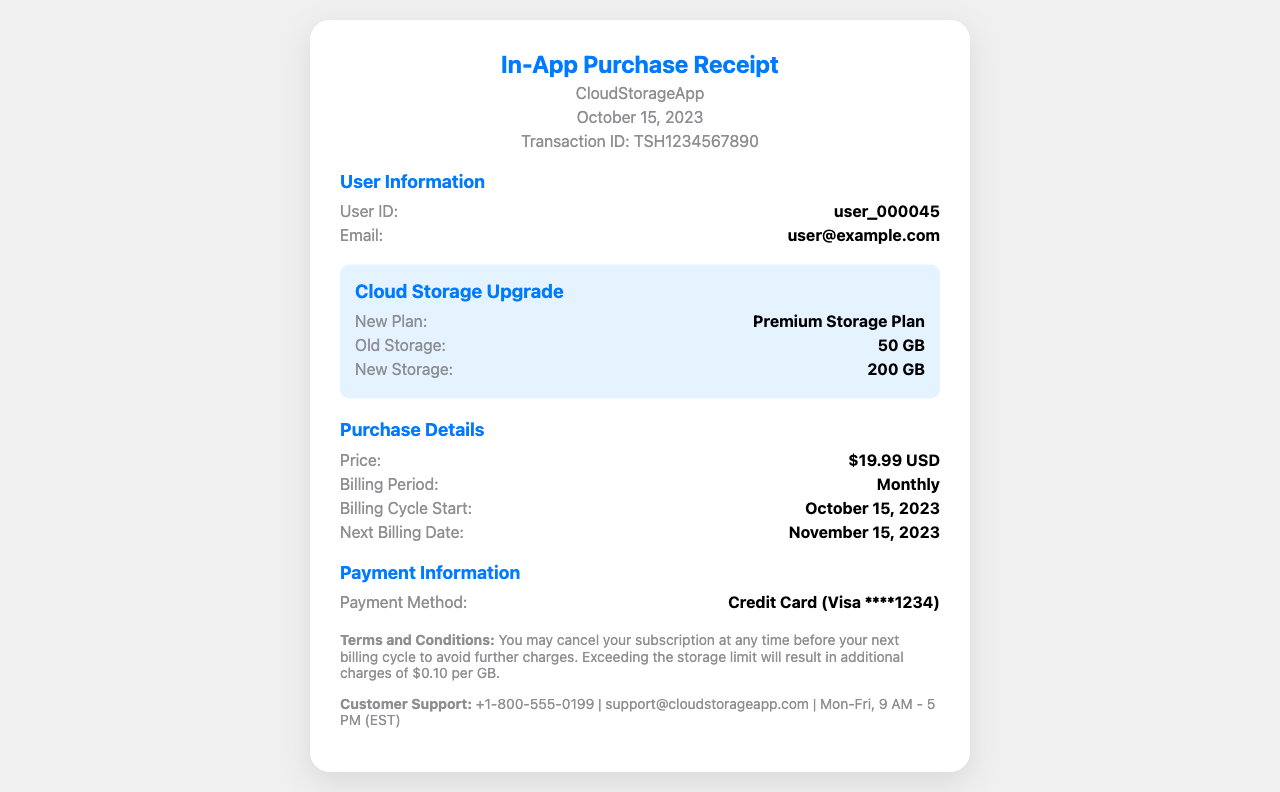What is the new storage limit? The document states that the new storage limit after the upgrade is 200 GB.
Answer: 200 GB What is the transaction ID? The transaction ID is provided in the receipt, which is TSH1234567890.
Answer: TSH1234567890 What was the old storage limit? The document mentions the old storage limit as 50 GB.
Answer: 50 GB What is the price of the cloud storage upgrade? The price for the cloud storage upgrade is clearly stated as $19.99 USD.
Answer: $19.99 USD When is the next billing date? The receipt indicates that the next billing date is November 15, 2023.
Answer: November 15, 2023 What payment method was used? The payment method used for the transaction is specified as Credit Card (Visa ****1234).
Answer: Credit Card (Visa ****1234) How often is the billing cycle? The billing period for the subscription is mentioned as Monthly.
Answer: Monthly What happens if the storage limit is exceeded? The document outlines that exceeding the storage limit will incur additional charges of $0.10 per GB.
Answer: $0.10 per GB 